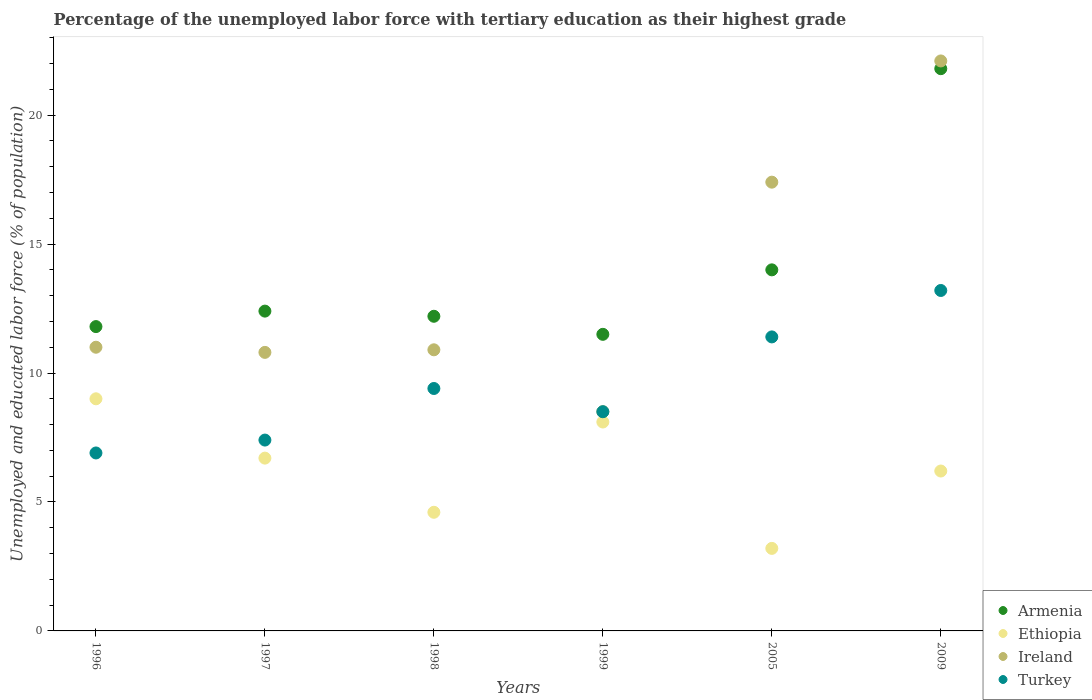What is the percentage of the unemployed labor force with tertiary education in Ethiopia in 1998?
Your answer should be compact. 4.6. Across all years, what is the maximum percentage of the unemployed labor force with tertiary education in Ireland?
Give a very brief answer. 22.1. In which year was the percentage of the unemployed labor force with tertiary education in Ireland maximum?
Give a very brief answer. 2009. In which year was the percentage of the unemployed labor force with tertiary education in Armenia minimum?
Provide a succinct answer. 1999. What is the total percentage of the unemployed labor force with tertiary education in Armenia in the graph?
Keep it short and to the point. 83.7. What is the difference between the percentage of the unemployed labor force with tertiary education in Ireland in 1997 and that in 2009?
Your answer should be compact. -11.3. What is the difference between the percentage of the unemployed labor force with tertiary education in Ethiopia in 1997 and the percentage of the unemployed labor force with tertiary education in Turkey in 2005?
Provide a succinct answer. -4.7. What is the average percentage of the unemployed labor force with tertiary education in Turkey per year?
Offer a terse response. 9.47. In the year 2005, what is the difference between the percentage of the unemployed labor force with tertiary education in Ireland and percentage of the unemployed labor force with tertiary education in Ethiopia?
Your response must be concise. 14.2. What is the ratio of the percentage of the unemployed labor force with tertiary education in Ethiopia in 1996 to that in 1999?
Provide a short and direct response. 1.11. Is the percentage of the unemployed labor force with tertiary education in Turkey in 1998 less than that in 2005?
Your answer should be very brief. Yes. Is the difference between the percentage of the unemployed labor force with tertiary education in Ireland in 1997 and 2005 greater than the difference between the percentage of the unemployed labor force with tertiary education in Ethiopia in 1997 and 2005?
Ensure brevity in your answer.  No. What is the difference between the highest and the second highest percentage of the unemployed labor force with tertiary education in Ethiopia?
Keep it short and to the point. 0.9. What is the difference between the highest and the lowest percentage of the unemployed labor force with tertiary education in Turkey?
Give a very brief answer. 6.3. Is the sum of the percentage of the unemployed labor force with tertiary education in Turkey in 1999 and 2009 greater than the maximum percentage of the unemployed labor force with tertiary education in Armenia across all years?
Provide a short and direct response. No. Is it the case that in every year, the sum of the percentage of the unemployed labor force with tertiary education in Ireland and percentage of the unemployed labor force with tertiary education in Turkey  is greater than the sum of percentage of the unemployed labor force with tertiary education in Ethiopia and percentage of the unemployed labor force with tertiary education in Armenia?
Make the answer very short. Yes. Is the percentage of the unemployed labor force with tertiary education in Ireland strictly greater than the percentage of the unemployed labor force with tertiary education in Armenia over the years?
Make the answer very short. No. Is the percentage of the unemployed labor force with tertiary education in Ireland strictly less than the percentage of the unemployed labor force with tertiary education in Ethiopia over the years?
Your response must be concise. No. How many dotlines are there?
Ensure brevity in your answer.  4. How many years are there in the graph?
Your response must be concise. 6. What is the difference between two consecutive major ticks on the Y-axis?
Ensure brevity in your answer.  5. Does the graph contain any zero values?
Give a very brief answer. No. How many legend labels are there?
Your response must be concise. 4. What is the title of the graph?
Ensure brevity in your answer.  Percentage of the unemployed labor force with tertiary education as their highest grade. Does "Cambodia" appear as one of the legend labels in the graph?
Make the answer very short. No. What is the label or title of the X-axis?
Your answer should be compact. Years. What is the label or title of the Y-axis?
Give a very brief answer. Unemployed and educated labor force (% of population). What is the Unemployed and educated labor force (% of population) of Armenia in 1996?
Offer a very short reply. 11.8. What is the Unemployed and educated labor force (% of population) in Ireland in 1996?
Provide a succinct answer. 11. What is the Unemployed and educated labor force (% of population) of Turkey in 1996?
Make the answer very short. 6.9. What is the Unemployed and educated labor force (% of population) in Armenia in 1997?
Provide a succinct answer. 12.4. What is the Unemployed and educated labor force (% of population) of Ethiopia in 1997?
Make the answer very short. 6.7. What is the Unemployed and educated labor force (% of population) of Ireland in 1997?
Give a very brief answer. 10.8. What is the Unemployed and educated labor force (% of population) in Turkey in 1997?
Provide a short and direct response. 7.4. What is the Unemployed and educated labor force (% of population) of Armenia in 1998?
Keep it short and to the point. 12.2. What is the Unemployed and educated labor force (% of population) in Ethiopia in 1998?
Offer a very short reply. 4.6. What is the Unemployed and educated labor force (% of population) of Ireland in 1998?
Offer a terse response. 10.9. What is the Unemployed and educated labor force (% of population) of Turkey in 1998?
Make the answer very short. 9.4. What is the Unemployed and educated labor force (% of population) of Armenia in 1999?
Provide a succinct answer. 11.5. What is the Unemployed and educated labor force (% of population) of Ethiopia in 1999?
Your response must be concise. 8.1. What is the Unemployed and educated labor force (% of population) of Turkey in 1999?
Provide a succinct answer. 8.5. What is the Unemployed and educated labor force (% of population) of Ethiopia in 2005?
Give a very brief answer. 3.2. What is the Unemployed and educated labor force (% of population) in Ireland in 2005?
Your response must be concise. 17.4. What is the Unemployed and educated labor force (% of population) of Turkey in 2005?
Ensure brevity in your answer.  11.4. What is the Unemployed and educated labor force (% of population) of Armenia in 2009?
Provide a succinct answer. 21.8. What is the Unemployed and educated labor force (% of population) in Ethiopia in 2009?
Provide a short and direct response. 6.2. What is the Unemployed and educated labor force (% of population) of Ireland in 2009?
Keep it short and to the point. 22.1. What is the Unemployed and educated labor force (% of population) of Turkey in 2009?
Offer a very short reply. 13.2. Across all years, what is the maximum Unemployed and educated labor force (% of population) of Armenia?
Your response must be concise. 21.8. Across all years, what is the maximum Unemployed and educated labor force (% of population) of Ireland?
Keep it short and to the point. 22.1. Across all years, what is the maximum Unemployed and educated labor force (% of population) of Turkey?
Provide a short and direct response. 13.2. Across all years, what is the minimum Unemployed and educated labor force (% of population) of Armenia?
Provide a short and direct response. 11.5. Across all years, what is the minimum Unemployed and educated labor force (% of population) of Ethiopia?
Keep it short and to the point. 3.2. Across all years, what is the minimum Unemployed and educated labor force (% of population) of Turkey?
Give a very brief answer. 6.9. What is the total Unemployed and educated labor force (% of population) of Armenia in the graph?
Your answer should be very brief. 83.7. What is the total Unemployed and educated labor force (% of population) of Ethiopia in the graph?
Provide a short and direct response. 37.8. What is the total Unemployed and educated labor force (% of population) of Ireland in the graph?
Your answer should be very brief. 80.7. What is the total Unemployed and educated labor force (% of population) of Turkey in the graph?
Your response must be concise. 56.8. What is the difference between the Unemployed and educated labor force (% of population) of Armenia in 1996 and that in 1997?
Give a very brief answer. -0.6. What is the difference between the Unemployed and educated labor force (% of population) in Ethiopia in 1996 and that in 1997?
Offer a terse response. 2.3. What is the difference between the Unemployed and educated labor force (% of population) in Ireland in 1996 and that in 1997?
Your answer should be very brief. 0.2. What is the difference between the Unemployed and educated labor force (% of population) in Turkey in 1996 and that in 1997?
Ensure brevity in your answer.  -0.5. What is the difference between the Unemployed and educated labor force (% of population) of Ethiopia in 1996 and that in 1998?
Provide a short and direct response. 4.4. What is the difference between the Unemployed and educated labor force (% of population) in Turkey in 1996 and that in 1998?
Ensure brevity in your answer.  -2.5. What is the difference between the Unemployed and educated labor force (% of population) of Armenia in 1996 and that in 1999?
Provide a succinct answer. 0.3. What is the difference between the Unemployed and educated labor force (% of population) of Ethiopia in 1996 and that in 1999?
Your answer should be compact. 0.9. What is the difference between the Unemployed and educated labor force (% of population) in Turkey in 1996 and that in 1999?
Ensure brevity in your answer.  -1.6. What is the difference between the Unemployed and educated labor force (% of population) of Ethiopia in 1996 and that in 2005?
Ensure brevity in your answer.  5.8. What is the difference between the Unemployed and educated labor force (% of population) of Turkey in 1996 and that in 2005?
Your response must be concise. -4.5. What is the difference between the Unemployed and educated labor force (% of population) of Armenia in 1996 and that in 2009?
Your answer should be compact. -10. What is the difference between the Unemployed and educated labor force (% of population) in Ethiopia in 1996 and that in 2009?
Give a very brief answer. 2.8. What is the difference between the Unemployed and educated labor force (% of population) of Ireland in 1996 and that in 2009?
Keep it short and to the point. -11.1. What is the difference between the Unemployed and educated labor force (% of population) of Turkey in 1997 and that in 1998?
Your answer should be compact. -2. What is the difference between the Unemployed and educated labor force (% of population) in Armenia in 1997 and that in 1999?
Provide a succinct answer. 0.9. What is the difference between the Unemployed and educated labor force (% of population) in Turkey in 1997 and that in 1999?
Your answer should be compact. -1.1. What is the difference between the Unemployed and educated labor force (% of population) in Armenia in 1997 and that in 2005?
Offer a terse response. -1.6. What is the difference between the Unemployed and educated labor force (% of population) of Ethiopia in 1997 and that in 2005?
Your answer should be very brief. 3.5. What is the difference between the Unemployed and educated labor force (% of population) of Armenia in 1997 and that in 2009?
Your response must be concise. -9.4. What is the difference between the Unemployed and educated labor force (% of population) in Ethiopia in 1997 and that in 2009?
Make the answer very short. 0.5. What is the difference between the Unemployed and educated labor force (% of population) of Turkey in 1997 and that in 2009?
Provide a succinct answer. -5.8. What is the difference between the Unemployed and educated labor force (% of population) in Armenia in 1998 and that in 1999?
Keep it short and to the point. 0.7. What is the difference between the Unemployed and educated labor force (% of population) in Ethiopia in 1998 and that in 1999?
Ensure brevity in your answer.  -3.5. What is the difference between the Unemployed and educated labor force (% of population) of Turkey in 1998 and that in 1999?
Make the answer very short. 0.9. What is the difference between the Unemployed and educated labor force (% of population) in Turkey in 1998 and that in 2009?
Offer a terse response. -3.8. What is the difference between the Unemployed and educated labor force (% of population) in Armenia in 1999 and that in 2005?
Make the answer very short. -2.5. What is the difference between the Unemployed and educated labor force (% of population) in Ethiopia in 1999 and that in 2005?
Give a very brief answer. 4.9. What is the difference between the Unemployed and educated labor force (% of population) in Turkey in 1999 and that in 2005?
Provide a succinct answer. -2.9. What is the difference between the Unemployed and educated labor force (% of population) of Armenia in 1999 and that in 2009?
Ensure brevity in your answer.  -10.3. What is the difference between the Unemployed and educated labor force (% of population) in Ethiopia in 1999 and that in 2009?
Your answer should be compact. 1.9. What is the difference between the Unemployed and educated labor force (% of population) in Ireland in 1999 and that in 2009?
Provide a short and direct response. -13.6. What is the difference between the Unemployed and educated labor force (% of population) in Armenia in 2005 and that in 2009?
Give a very brief answer. -7.8. What is the difference between the Unemployed and educated labor force (% of population) in Turkey in 2005 and that in 2009?
Provide a succinct answer. -1.8. What is the difference between the Unemployed and educated labor force (% of population) in Armenia in 1996 and the Unemployed and educated labor force (% of population) in Turkey in 1997?
Give a very brief answer. 4.4. What is the difference between the Unemployed and educated labor force (% of population) of Ethiopia in 1996 and the Unemployed and educated labor force (% of population) of Ireland in 1997?
Provide a short and direct response. -1.8. What is the difference between the Unemployed and educated labor force (% of population) of Armenia in 1996 and the Unemployed and educated labor force (% of population) of Ireland in 1998?
Give a very brief answer. 0.9. What is the difference between the Unemployed and educated labor force (% of population) in Ethiopia in 1996 and the Unemployed and educated labor force (% of population) in Ireland in 1998?
Make the answer very short. -1.9. What is the difference between the Unemployed and educated labor force (% of population) in Ethiopia in 1996 and the Unemployed and educated labor force (% of population) in Turkey in 1998?
Your answer should be very brief. -0.4. What is the difference between the Unemployed and educated labor force (% of population) in Armenia in 1996 and the Unemployed and educated labor force (% of population) in Ethiopia in 1999?
Offer a very short reply. 3.7. What is the difference between the Unemployed and educated labor force (% of population) of Armenia in 1996 and the Unemployed and educated labor force (% of population) of Ireland in 1999?
Your answer should be compact. 3.3. What is the difference between the Unemployed and educated labor force (% of population) of Ethiopia in 1996 and the Unemployed and educated labor force (% of population) of Ireland in 1999?
Ensure brevity in your answer.  0.5. What is the difference between the Unemployed and educated labor force (% of population) in Ethiopia in 1996 and the Unemployed and educated labor force (% of population) in Turkey in 1999?
Offer a terse response. 0.5. What is the difference between the Unemployed and educated labor force (% of population) in Ireland in 1996 and the Unemployed and educated labor force (% of population) in Turkey in 1999?
Your answer should be very brief. 2.5. What is the difference between the Unemployed and educated labor force (% of population) of Armenia in 1996 and the Unemployed and educated labor force (% of population) of Ireland in 2005?
Make the answer very short. -5.6. What is the difference between the Unemployed and educated labor force (% of population) of Armenia in 1996 and the Unemployed and educated labor force (% of population) of Turkey in 2005?
Provide a short and direct response. 0.4. What is the difference between the Unemployed and educated labor force (% of population) of Ethiopia in 1996 and the Unemployed and educated labor force (% of population) of Turkey in 2005?
Provide a succinct answer. -2.4. What is the difference between the Unemployed and educated labor force (% of population) of Armenia in 1996 and the Unemployed and educated labor force (% of population) of Ethiopia in 2009?
Offer a very short reply. 5.6. What is the difference between the Unemployed and educated labor force (% of population) of Armenia in 1996 and the Unemployed and educated labor force (% of population) of Ireland in 2009?
Your answer should be very brief. -10.3. What is the difference between the Unemployed and educated labor force (% of population) of Ethiopia in 1996 and the Unemployed and educated labor force (% of population) of Ireland in 2009?
Provide a short and direct response. -13.1. What is the difference between the Unemployed and educated labor force (% of population) of Ethiopia in 1997 and the Unemployed and educated labor force (% of population) of Turkey in 1998?
Your answer should be very brief. -2.7. What is the difference between the Unemployed and educated labor force (% of population) in Ireland in 1997 and the Unemployed and educated labor force (% of population) in Turkey in 1998?
Your answer should be compact. 1.4. What is the difference between the Unemployed and educated labor force (% of population) of Armenia in 1997 and the Unemployed and educated labor force (% of population) of Ireland in 1999?
Your answer should be very brief. 3.9. What is the difference between the Unemployed and educated labor force (% of population) of Ethiopia in 1997 and the Unemployed and educated labor force (% of population) of Ireland in 1999?
Make the answer very short. -1.8. What is the difference between the Unemployed and educated labor force (% of population) in Ethiopia in 1997 and the Unemployed and educated labor force (% of population) in Turkey in 1999?
Your response must be concise. -1.8. What is the difference between the Unemployed and educated labor force (% of population) of Ireland in 1997 and the Unemployed and educated labor force (% of population) of Turkey in 1999?
Your answer should be compact. 2.3. What is the difference between the Unemployed and educated labor force (% of population) in Armenia in 1997 and the Unemployed and educated labor force (% of population) in Ethiopia in 2005?
Your answer should be compact. 9.2. What is the difference between the Unemployed and educated labor force (% of population) in Armenia in 1997 and the Unemployed and educated labor force (% of population) in Turkey in 2005?
Make the answer very short. 1. What is the difference between the Unemployed and educated labor force (% of population) of Ethiopia in 1997 and the Unemployed and educated labor force (% of population) of Ireland in 2005?
Provide a succinct answer. -10.7. What is the difference between the Unemployed and educated labor force (% of population) in Ethiopia in 1997 and the Unemployed and educated labor force (% of population) in Turkey in 2005?
Your answer should be very brief. -4.7. What is the difference between the Unemployed and educated labor force (% of population) of Armenia in 1997 and the Unemployed and educated labor force (% of population) of Turkey in 2009?
Keep it short and to the point. -0.8. What is the difference between the Unemployed and educated labor force (% of population) in Ethiopia in 1997 and the Unemployed and educated labor force (% of population) in Ireland in 2009?
Keep it short and to the point. -15.4. What is the difference between the Unemployed and educated labor force (% of population) in Ethiopia in 1997 and the Unemployed and educated labor force (% of population) in Turkey in 2009?
Provide a short and direct response. -6.5. What is the difference between the Unemployed and educated labor force (% of population) in Armenia in 1998 and the Unemployed and educated labor force (% of population) in Ireland in 1999?
Give a very brief answer. 3.7. What is the difference between the Unemployed and educated labor force (% of population) of Ethiopia in 1998 and the Unemployed and educated labor force (% of population) of Ireland in 1999?
Give a very brief answer. -3.9. What is the difference between the Unemployed and educated labor force (% of population) in Ireland in 1998 and the Unemployed and educated labor force (% of population) in Turkey in 1999?
Make the answer very short. 2.4. What is the difference between the Unemployed and educated labor force (% of population) in Ethiopia in 1998 and the Unemployed and educated labor force (% of population) in Turkey in 2005?
Offer a very short reply. -6.8. What is the difference between the Unemployed and educated labor force (% of population) in Armenia in 1998 and the Unemployed and educated labor force (% of population) in Ireland in 2009?
Give a very brief answer. -9.9. What is the difference between the Unemployed and educated labor force (% of population) of Ethiopia in 1998 and the Unemployed and educated labor force (% of population) of Ireland in 2009?
Your answer should be very brief. -17.5. What is the difference between the Unemployed and educated labor force (% of population) in Armenia in 1999 and the Unemployed and educated labor force (% of population) in Ethiopia in 2005?
Your answer should be compact. 8.3. What is the difference between the Unemployed and educated labor force (% of population) in Ethiopia in 1999 and the Unemployed and educated labor force (% of population) in Turkey in 2005?
Keep it short and to the point. -3.3. What is the difference between the Unemployed and educated labor force (% of population) of Ireland in 1999 and the Unemployed and educated labor force (% of population) of Turkey in 2005?
Give a very brief answer. -2.9. What is the difference between the Unemployed and educated labor force (% of population) in Armenia in 1999 and the Unemployed and educated labor force (% of population) in Turkey in 2009?
Keep it short and to the point. -1.7. What is the difference between the Unemployed and educated labor force (% of population) of Ireland in 1999 and the Unemployed and educated labor force (% of population) of Turkey in 2009?
Offer a very short reply. -4.7. What is the difference between the Unemployed and educated labor force (% of population) in Armenia in 2005 and the Unemployed and educated labor force (% of population) in Ethiopia in 2009?
Ensure brevity in your answer.  7.8. What is the difference between the Unemployed and educated labor force (% of population) in Armenia in 2005 and the Unemployed and educated labor force (% of population) in Ireland in 2009?
Ensure brevity in your answer.  -8.1. What is the difference between the Unemployed and educated labor force (% of population) in Armenia in 2005 and the Unemployed and educated labor force (% of population) in Turkey in 2009?
Your response must be concise. 0.8. What is the difference between the Unemployed and educated labor force (% of population) of Ethiopia in 2005 and the Unemployed and educated labor force (% of population) of Ireland in 2009?
Offer a very short reply. -18.9. What is the difference between the Unemployed and educated labor force (% of population) in Ireland in 2005 and the Unemployed and educated labor force (% of population) in Turkey in 2009?
Offer a terse response. 4.2. What is the average Unemployed and educated labor force (% of population) in Armenia per year?
Give a very brief answer. 13.95. What is the average Unemployed and educated labor force (% of population) of Ireland per year?
Give a very brief answer. 13.45. What is the average Unemployed and educated labor force (% of population) of Turkey per year?
Your response must be concise. 9.47. In the year 1996, what is the difference between the Unemployed and educated labor force (% of population) of Armenia and Unemployed and educated labor force (% of population) of Ethiopia?
Make the answer very short. 2.8. In the year 1996, what is the difference between the Unemployed and educated labor force (% of population) of Armenia and Unemployed and educated labor force (% of population) of Turkey?
Provide a short and direct response. 4.9. In the year 1996, what is the difference between the Unemployed and educated labor force (% of population) of Ethiopia and Unemployed and educated labor force (% of population) of Ireland?
Your answer should be very brief. -2. In the year 1996, what is the difference between the Unemployed and educated labor force (% of population) of Ireland and Unemployed and educated labor force (% of population) of Turkey?
Make the answer very short. 4.1. In the year 1997, what is the difference between the Unemployed and educated labor force (% of population) in Armenia and Unemployed and educated labor force (% of population) in Turkey?
Provide a short and direct response. 5. In the year 1997, what is the difference between the Unemployed and educated labor force (% of population) in Ireland and Unemployed and educated labor force (% of population) in Turkey?
Keep it short and to the point. 3.4. In the year 1998, what is the difference between the Unemployed and educated labor force (% of population) of Armenia and Unemployed and educated labor force (% of population) of Ethiopia?
Ensure brevity in your answer.  7.6. In the year 1998, what is the difference between the Unemployed and educated labor force (% of population) of Armenia and Unemployed and educated labor force (% of population) of Turkey?
Make the answer very short. 2.8. In the year 1999, what is the difference between the Unemployed and educated labor force (% of population) of Armenia and Unemployed and educated labor force (% of population) of Ethiopia?
Offer a terse response. 3.4. In the year 1999, what is the difference between the Unemployed and educated labor force (% of population) of Armenia and Unemployed and educated labor force (% of population) of Turkey?
Ensure brevity in your answer.  3. In the year 1999, what is the difference between the Unemployed and educated labor force (% of population) in Ireland and Unemployed and educated labor force (% of population) in Turkey?
Your answer should be very brief. 0. In the year 2005, what is the difference between the Unemployed and educated labor force (% of population) of Armenia and Unemployed and educated labor force (% of population) of Ireland?
Provide a succinct answer. -3.4. In the year 2005, what is the difference between the Unemployed and educated labor force (% of population) of Armenia and Unemployed and educated labor force (% of population) of Turkey?
Your response must be concise. 2.6. In the year 2005, what is the difference between the Unemployed and educated labor force (% of population) in Ethiopia and Unemployed and educated labor force (% of population) in Ireland?
Give a very brief answer. -14.2. In the year 2005, what is the difference between the Unemployed and educated labor force (% of population) in Ireland and Unemployed and educated labor force (% of population) in Turkey?
Provide a succinct answer. 6. In the year 2009, what is the difference between the Unemployed and educated labor force (% of population) in Armenia and Unemployed and educated labor force (% of population) in Ethiopia?
Offer a terse response. 15.6. In the year 2009, what is the difference between the Unemployed and educated labor force (% of population) of Armenia and Unemployed and educated labor force (% of population) of Ireland?
Offer a very short reply. -0.3. In the year 2009, what is the difference between the Unemployed and educated labor force (% of population) in Armenia and Unemployed and educated labor force (% of population) in Turkey?
Your answer should be very brief. 8.6. In the year 2009, what is the difference between the Unemployed and educated labor force (% of population) in Ethiopia and Unemployed and educated labor force (% of population) in Ireland?
Offer a terse response. -15.9. In the year 2009, what is the difference between the Unemployed and educated labor force (% of population) of Ethiopia and Unemployed and educated labor force (% of population) of Turkey?
Give a very brief answer. -7. What is the ratio of the Unemployed and educated labor force (% of population) in Armenia in 1996 to that in 1997?
Offer a very short reply. 0.95. What is the ratio of the Unemployed and educated labor force (% of population) of Ethiopia in 1996 to that in 1997?
Your answer should be compact. 1.34. What is the ratio of the Unemployed and educated labor force (% of population) of Ireland in 1996 to that in 1997?
Your answer should be compact. 1.02. What is the ratio of the Unemployed and educated labor force (% of population) in Turkey in 1996 to that in 1997?
Provide a short and direct response. 0.93. What is the ratio of the Unemployed and educated labor force (% of population) of Armenia in 1996 to that in 1998?
Provide a succinct answer. 0.97. What is the ratio of the Unemployed and educated labor force (% of population) in Ethiopia in 1996 to that in 1998?
Your answer should be very brief. 1.96. What is the ratio of the Unemployed and educated labor force (% of population) in Ireland in 1996 to that in 1998?
Make the answer very short. 1.01. What is the ratio of the Unemployed and educated labor force (% of population) of Turkey in 1996 to that in 1998?
Make the answer very short. 0.73. What is the ratio of the Unemployed and educated labor force (% of population) of Armenia in 1996 to that in 1999?
Provide a short and direct response. 1.03. What is the ratio of the Unemployed and educated labor force (% of population) in Ireland in 1996 to that in 1999?
Make the answer very short. 1.29. What is the ratio of the Unemployed and educated labor force (% of population) of Turkey in 1996 to that in 1999?
Your answer should be compact. 0.81. What is the ratio of the Unemployed and educated labor force (% of population) in Armenia in 1996 to that in 2005?
Offer a terse response. 0.84. What is the ratio of the Unemployed and educated labor force (% of population) in Ethiopia in 1996 to that in 2005?
Provide a succinct answer. 2.81. What is the ratio of the Unemployed and educated labor force (% of population) of Ireland in 1996 to that in 2005?
Make the answer very short. 0.63. What is the ratio of the Unemployed and educated labor force (% of population) in Turkey in 1996 to that in 2005?
Offer a terse response. 0.61. What is the ratio of the Unemployed and educated labor force (% of population) of Armenia in 1996 to that in 2009?
Provide a succinct answer. 0.54. What is the ratio of the Unemployed and educated labor force (% of population) of Ethiopia in 1996 to that in 2009?
Your answer should be compact. 1.45. What is the ratio of the Unemployed and educated labor force (% of population) of Ireland in 1996 to that in 2009?
Keep it short and to the point. 0.5. What is the ratio of the Unemployed and educated labor force (% of population) in Turkey in 1996 to that in 2009?
Offer a terse response. 0.52. What is the ratio of the Unemployed and educated labor force (% of population) in Armenia in 1997 to that in 1998?
Keep it short and to the point. 1.02. What is the ratio of the Unemployed and educated labor force (% of population) in Ethiopia in 1997 to that in 1998?
Provide a short and direct response. 1.46. What is the ratio of the Unemployed and educated labor force (% of population) in Turkey in 1997 to that in 1998?
Ensure brevity in your answer.  0.79. What is the ratio of the Unemployed and educated labor force (% of population) in Armenia in 1997 to that in 1999?
Ensure brevity in your answer.  1.08. What is the ratio of the Unemployed and educated labor force (% of population) of Ethiopia in 1997 to that in 1999?
Your answer should be very brief. 0.83. What is the ratio of the Unemployed and educated labor force (% of population) in Ireland in 1997 to that in 1999?
Provide a short and direct response. 1.27. What is the ratio of the Unemployed and educated labor force (% of population) in Turkey in 1997 to that in 1999?
Offer a terse response. 0.87. What is the ratio of the Unemployed and educated labor force (% of population) of Armenia in 1997 to that in 2005?
Keep it short and to the point. 0.89. What is the ratio of the Unemployed and educated labor force (% of population) of Ethiopia in 1997 to that in 2005?
Offer a terse response. 2.09. What is the ratio of the Unemployed and educated labor force (% of population) in Ireland in 1997 to that in 2005?
Your answer should be compact. 0.62. What is the ratio of the Unemployed and educated labor force (% of population) in Turkey in 1997 to that in 2005?
Provide a succinct answer. 0.65. What is the ratio of the Unemployed and educated labor force (% of population) of Armenia in 1997 to that in 2009?
Offer a very short reply. 0.57. What is the ratio of the Unemployed and educated labor force (% of population) in Ethiopia in 1997 to that in 2009?
Your response must be concise. 1.08. What is the ratio of the Unemployed and educated labor force (% of population) of Ireland in 1997 to that in 2009?
Give a very brief answer. 0.49. What is the ratio of the Unemployed and educated labor force (% of population) of Turkey in 1997 to that in 2009?
Make the answer very short. 0.56. What is the ratio of the Unemployed and educated labor force (% of population) in Armenia in 1998 to that in 1999?
Provide a short and direct response. 1.06. What is the ratio of the Unemployed and educated labor force (% of population) of Ethiopia in 1998 to that in 1999?
Offer a very short reply. 0.57. What is the ratio of the Unemployed and educated labor force (% of population) in Ireland in 1998 to that in 1999?
Keep it short and to the point. 1.28. What is the ratio of the Unemployed and educated labor force (% of population) in Turkey in 1998 to that in 1999?
Your response must be concise. 1.11. What is the ratio of the Unemployed and educated labor force (% of population) in Armenia in 1998 to that in 2005?
Give a very brief answer. 0.87. What is the ratio of the Unemployed and educated labor force (% of population) in Ethiopia in 1998 to that in 2005?
Your response must be concise. 1.44. What is the ratio of the Unemployed and educated labor force (% of population) in Ireland in 1998 to that in 2005?
Keep it short and to the point. 0.63. What is the ratio of the Unemployed and educated labor force (% of population) of Turkey in 1998 to that in 2005?
Ensure brevity in your answer.  0.82. What is the ratio of the Unemployed and educated labor force (% of population) of Armenia in 1998 to that in 2009?
Offer a very short reply. 0.56. What is the ratio of the Unemployed and educated labor force (% of population) of Ethiopia in 1998 to that in 2009?
Keep it short and to the point. 0.74. What is the ratio of the Unemployed and educated labor force (% of population) in Ireland in 1998 to that in 2009?
Give a very brief answer. 0.49. What is the ratio of the Unemployed and educated labor force (% of population) in Turkey in 1998 to that in 2009?
Your answer should be compact. 0.71. What is the ratio of the Unemployed and educated labor force (% of population) in Armenia in 1999 to that in 2005?
Offer a very short reply. 0.82. What is the ratio of the Unemployed and educated labor force (% of population) in Ethiopia in 1999 to that in 2005?
Provide a short and direct response. 2.53. What is the ratio of the Unemployed and educated labor force (% of population) of Ireland in 1999 to that in 2005?
Offer a very short reply. 0.49. What is the ratio of the Unemployed and educated labor force (% of population) of Turkey in 1999 to that in 2005?
Your answer should be very brief. 0.75. What is the ratio of the Unemployed and educated labor force (% of population) in Armenia in 1999 to that in 2009?
Offer a very short reply. 0.53. What is the ratio of the Unemployed and educated labor force (% of population) in Ethiopia in 1999 to that in 2009?
Provide a short and direct response. 1.31. What is the ratio of the Unemployed and educated labor force (% of population) in Ireland in 1999 to that in 2009?
Give a very brief answer. 0.38. What is the ratio of the Unemployed and educated labor force (% of population) in Turkey in 1999 to that in 2009?
Ensure brevity in your answer.  0.64. What is the ratio of the Unemployed and educated labor force (% of population) in Armenia in 2005 to that in 2009?
Make the answer very short. 0.64. What is the ratio of the Unemployed and educated labor force (% of population) in Ethiopia in 2005 to that in 2009?
Your answer should be compact. 0.52. What is the ratio of the Unemployed and educated labor force (% of population) in Ireland in 2005 to that in 2009?
Ensure brevity in your answer.  0.79. What is the ratio of the Unemployed and educated labor force (% of population) of Turkey in 2005 to that in 2009?
Offer a very short reply. 0.86. What is the difference between the highest and the second highest Unemployed and educated labor force (% of population) in Armenia?
Provide a short and direct response. 7.8. What is the difference between the highest and the second highest Unemployed and educated labor force (% of population) of Turkey?
Your response must be concise. 1.8. What is the difference between the highest and the lowest Unemployed and educated labor force (% of population) of Ireland?
Offer a terse response. 13.6. What is the difference between the highest and the lowest Unemployed and educated labor force (% of population) in Turkey?
Provide a succinct answer. 6.3. 